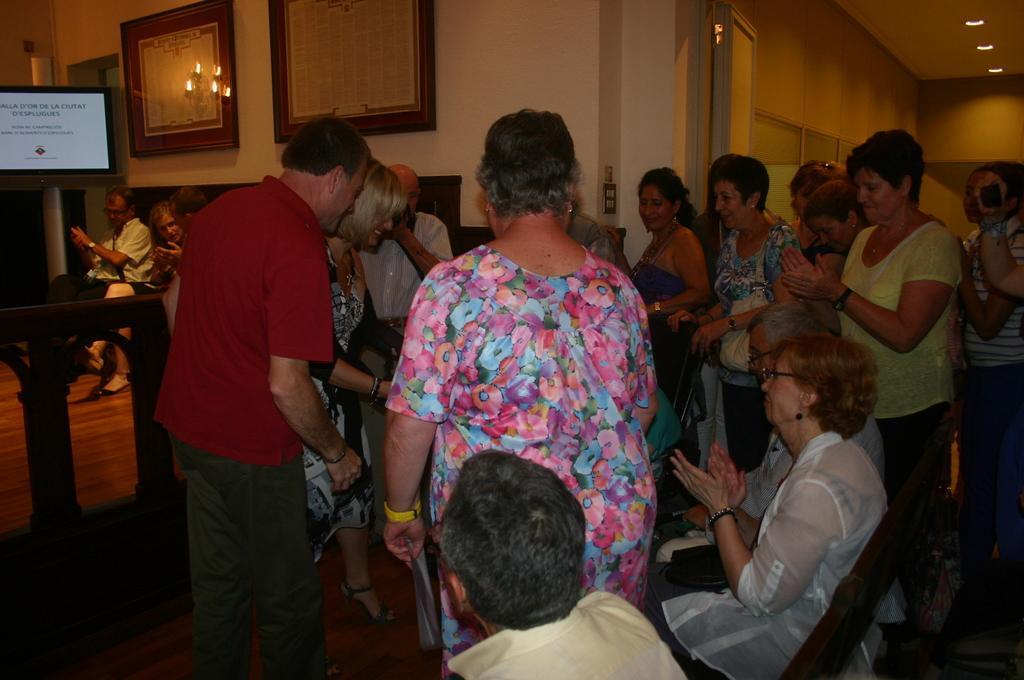Can you describe this image briefly? In this image, we can see a group of people are sitting and standing. Here we can see few people are clapping their hands. Left side of the image, we can see a screen photo frames, wall, door and lights. 